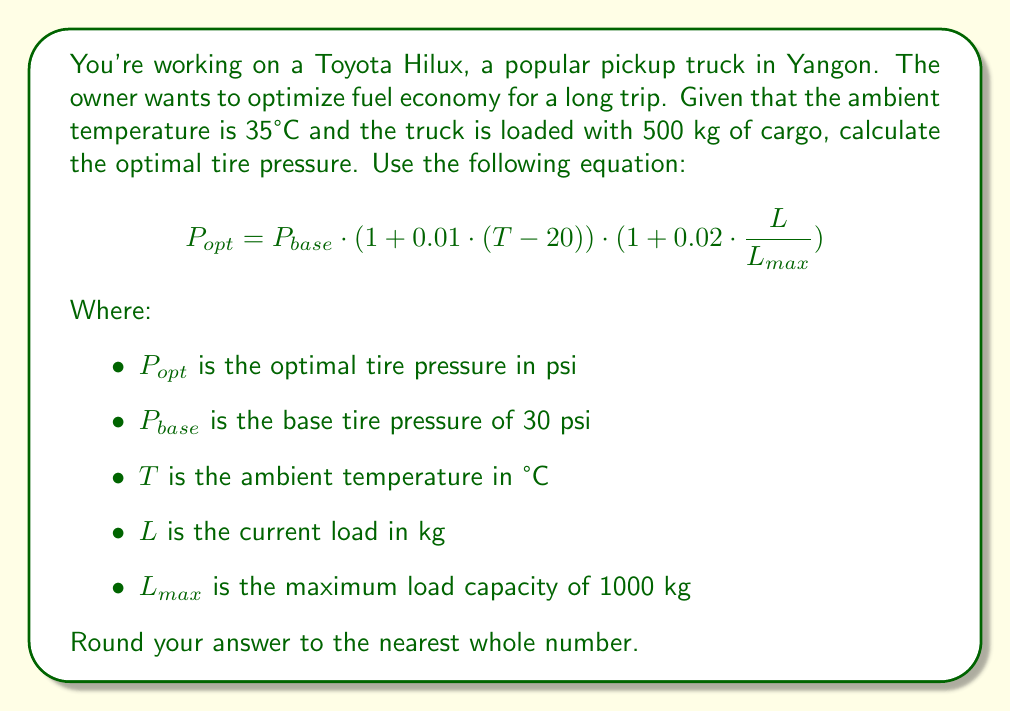Could you help me with this problem? Let's solve this problem step by step:

1) We're given the following information:
   $P_{base} = 30$ psi
   $T = 35°C$
   $L = 500$ kg
   $L_{max} = 1000$ kg

2) Let's substitute these values into the equation:

   $$P_{opt} = 30 \cdot (1 + 0.01 \cdot (35 - 20)) \cdot (1 + 0.02 \cdot \frac{500}{1000})$$

3) First, let's calculate the temperature adjustment:
   $(1 + 0.01 \cdot (35 - 20)) = (1 + 0.01 \cdot 15) = 1.15$

4) Next, let's calculate the load adjustment:
   $(1 + 0.02 \cdot \frac{500}{1000}) = (1 + 0.02 \cdot 0.5) = 1.01$

5) Now, let's multiply all the terms:
   $$P_{opt} = 30 \cdot 1.15 \cdot 1.01 = 34.845$$

6) Rounding to the nearest whole number:
   $P_{opt} \approx 35$ psi
Answer: 35 psi 